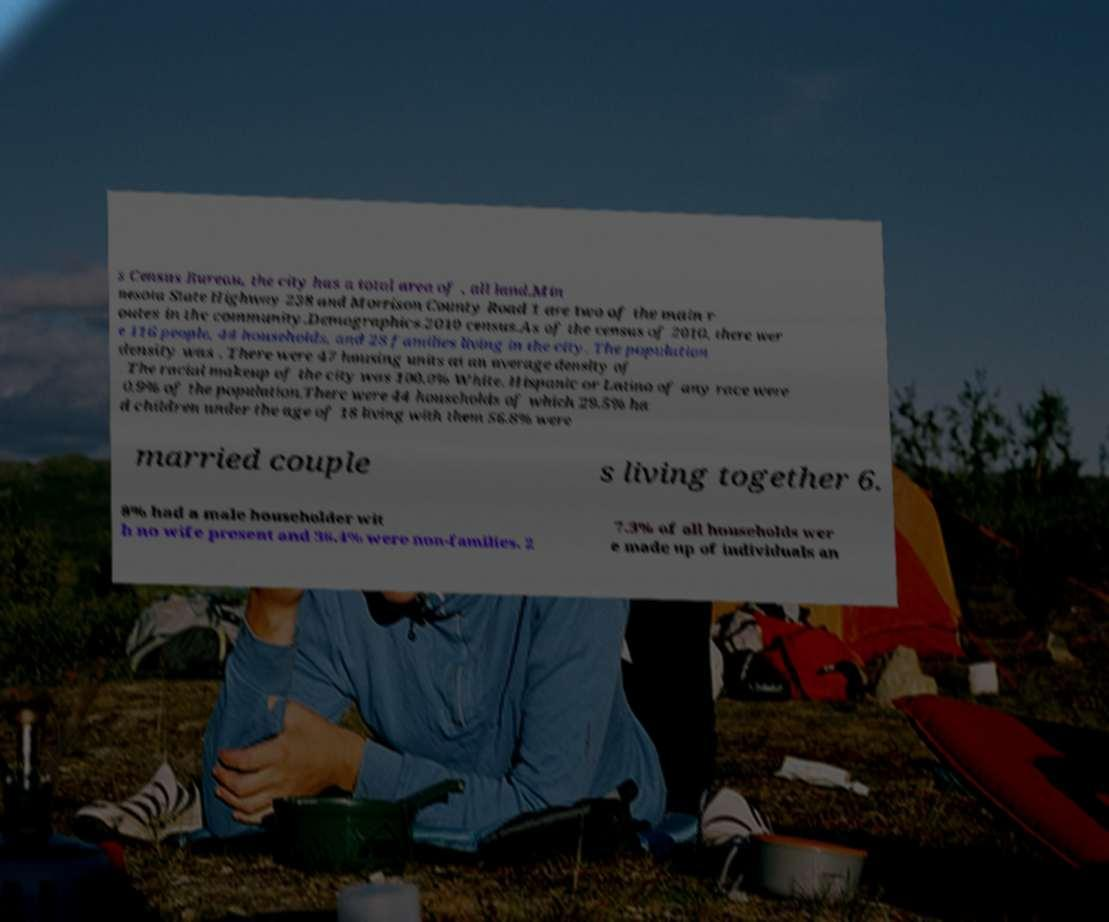Please identify and transcribe the text found in this image. s Census Bureau, the city has a total area of , all land.Min nesota State Highway 238 and Morrison County Road 1 are two of the main r outes in the community.Demographics.2010 census.As of the census of 2010, there wer e 116 people, 44 households, and 28 families living in the city. The population density was . There were 47 housing units at an average density of . The racial makeup of the city was 100.0% White. Hispanic or Latino of any race were 0.9% of the population.There were 44 households of which 29.5% ha d children under the age of 18 living with them 56.8% were married couple s living together 6. 8% had a male householder wit h no wife present and 36.4% were non-families. 2 7.3% of all households wer e made up of individuals an 